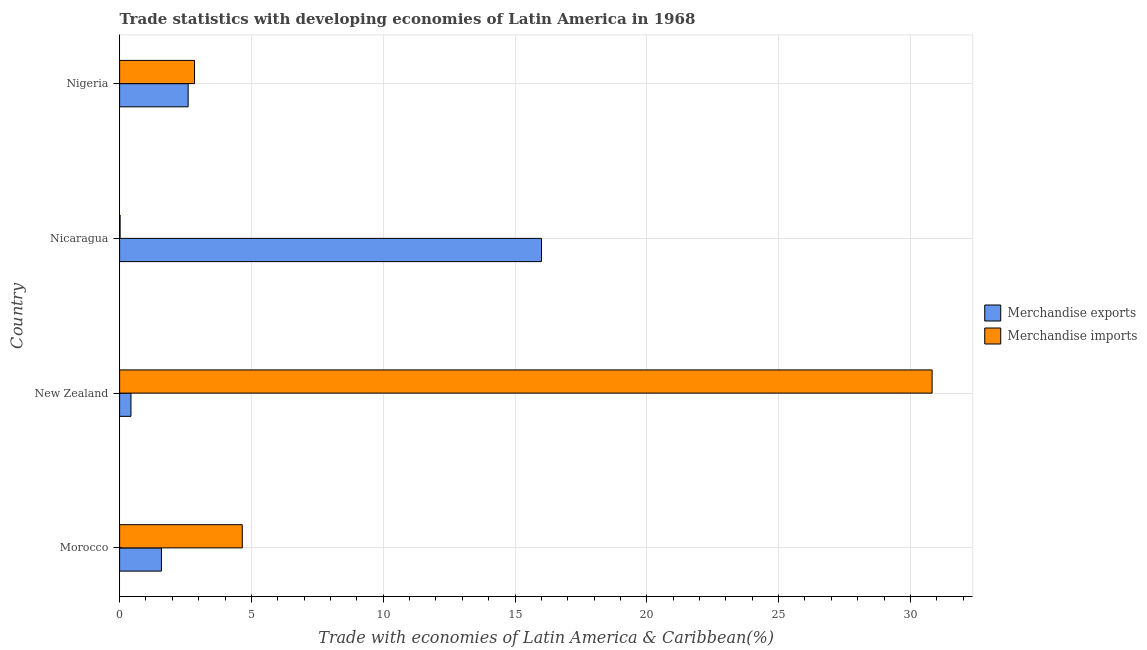How many bars are there on the 4th tick from the top?
Your answer should be compact. 2. How many bars are there on the 4th tick from the bottom?
Offer a terse response. 2. What is the label of the 1st group of bars from the top?
Offer a very short reply. Nigeria. What is the merchandise imports in New Zealand?
Ensure brevity in your answer.  30.82. Across all countries, what is the maximum merchandise exports?
Provide a succinct answer. 16. Across all countries, what is the minimum merchandise imports?
Provide a short and direct response. 0.02. In which country was the merchandise exports maximum?
Provide a short and direct response. Nicaragua. In which country was the merchandise imports minimum?
Provide a short and direct response. Nicaragua. What is the total merchandise imports in the graph?
Offer a terse response. 38.34. What is the difference between the merchandise exports in Morocco and that in New Zealand?
Provide a short and direct response. 1.16. What is the difference between the merchandise imports in New Zealand and the merchandise exports in Nicaragua?
Ensure brevity in your answer.  14.82. What is the average merchandise imports per country?
Ensure brevity in your answer.  9.59. What is the difference between the merchandise exports and merchandise imports in Morocco?
Your answer should be very brief. -3.07. What is the ratio of the merchandise exports in Morocco to that in New Zealand?
Offer a very short reply. 3.68. Is the merchandise imports in New Zealand less than that in Nicaragua?
Your answer should be compact. No. What is the difference between the highest and the second highest merchandise imports?
Offer a terse response. 26.17. What is the difference between the highest and the lowest merchandise imports?
Your answer should be very brief. 30.81. Is the sum of the merchandise imports in Morocco and Nigeria greater than the maximum merchandise exports across all countries?
Keep it short and to the point. No. What does the 1st bar from the top in Morocco represents?
Make the answer very short. Merchandise imports. What does the 1st bar from the bottom in New Zealand represents?
Keep it short and to the point. Merchandise exports. How many bars are there?
Offer a very short reply. 8. Are all the bars in the graph horizontal?
Your answer should be compact. Yes. What is the difference between two consecutive major ticks on the X-axis?
Your answer should be compact. 5. Does the graph contain any zero values?
Offer a very short reply. No. Does the graph contain grids?
Offer a terse response. Yes. Where does the legend appear in the graph?
Keep it short and to the point. Center right. What is the title of the graph?
Make the answer very short. Trade statistics with developing economies of Latin America in 1968. Does "RDB nonconcessional" appear as one of the legend labels in the graph?
Give a very brief answer. No. What is the label or title of the X-axis?
Provide a succinct answer. Trade with economies of Latin America & Caribbean(%). What is the Trade with economies of Latin America & Caribbean(%) of Merchandise exports in Morocco?
Make the answer very short. 1.59. What is the Trade with economies of Latin America & Caribbean(%) of Merchandise imports in Morocco?
Offer a terse response. 4.65. What is the Trade with economies of Latin America & Caribbean(%) of Merchandise exports in New Zealand?
Your response must be concise. 0.43. What is the Trade with economies of Latin America & Caribbean(%) of Merchandise imports in New Zealand?
Keep it short and to the point. 30.82. What is the Trade with economies of Latin America & Caribbean(%) in Merchandise exports in Nicaragua?
Make the answer very short. 16. What is the Trade with economies of Latin America & Caribbean(%) of Merchandise imports in Nicaragua?
Ensure brevity in your answer.  0.02. What is the Trade with economies of Latin America & Caribbean(%) of Merchandise exports in Nigeria?
Your answer should be very brief. 2.6. What is the Trade with economies of Latin America & Caribbean(%) of Merchandise imports in Nigeria?
Your answer should be very brief. 2.84. Across all countries, what is the maximum Trade with economies of Latin America & Caribbean(%) of Merchandise exports?
Give a very brief answer. 16. Across all countries, what is the maximum Trade with economies of Latin America & Caribbean(%) in Merchandise imports?
Give a very brief answer. 30.82. Across all countries, what is the minimum Trade with economies of Latin America & Caribbean(%) of Merchandise exports?
Provide a succinct answer. 0.43. Across all countries, what is the minimum Trade with economies of Latin America & Caribbean(%) of Merchandise imports?
Your answer should be compact. 0.02. What is the total Trade with economies of Latin America & Caribbean(%) in Merchandise exports in the graph?
Give a very brief answer. 20.62. What is the total Trade with economies of Latin America & Caribbean(%) of Merchandise imports in the graph?
Provide a succinct answer. 38.34. What is the difference between the Trade with economies of Latin America & Caribbean(%) of Merchandise exports in Morocco and that in New Zealand?
Make the answer very short. 1.16. What is the difference between the Trade with economies of Latin America & Caribbean(%) in Merchandise imports in Morocco and that in New Zealand?
Your answer should be very brief. -26.17. What is the difference between the Trade with economies of Latin America & Caribbean(%) in Merchandise exports in Morocco and that in Nicaragua?
Make the answer very short. -14.42. What is the difference between the Trade with economies of Latin America & Caribbean(%) in Merchandise imports in Morocco and that in Nicaragua?
Make the answer very short. 4.64. What is the difference between the Trade with economies of Latin America & Caribbean(%) in Merchandise exports in Morocco and that in Nigeria?
Give a very brief answer. -1.01. What is the difference between the Trade with economies of Latin America & Caribbean(%) in Merchandise imports in Morocco and that in Nigeria?
Offer a terse response. 1.81. What is the difference between the Trade with economies of Latin America & Caribbean(%) of Merchandise exports in New Zealand and that in Nicaragua?
Offer a very short reply. -15.57. What is the difference between the Trade with economies of Latin America & Caribbean(%) of Merchandise imports in New Zealand and that in Nicaragua?
Keep it short and to the point. 30.81. What is the difference between the Trade with economies of Latin America & Caribbean(%) of Merchandise exports in New Zealand and that in Nigeria?
Offer a terse response. -2.17. What is the difference between the Trade with economies of Latin America & Caribbean(%) in Merchandise imports in New Zealand and that in Nigeria?
Offer a terse response. 27.98. What is the difference between the Trade with economies of Latin America & Caribbean(%) in Merchandise exports in Nicaragua and that in Nigeria?
Offer a very short reply. 13.4. What is the difference between the Trade with economies of Latin America & Caribbean(%) of Merchandise imports in Nicaragua and that in Nigeria?
Your answer should be very brief. -2.82. What is the difference between the Trade with economies of Latin America & Caribbean(%) in Merchandise exports in Morocco and the Trade with economies of Latin America & Caribbean(%) in Merchandise imports in New Zealand?
Give a very brief answer. -29.24. What is the difference between the Trade with economies of Latin America & Caribbean(%) in Merchandise exports in Morocco and the Trade with economies of Latin America & Caribbean(%) in Merchandise imports in Nicaragua?
Your answer should be compact. 1.57. What is the difference between the Trade with economies of Latin America & Caribbean(%) in Merchandise exports in Morocco and the Trade with economies of Latin America & Caribbean(%) in Merchandise imports in Nigeria?
Provide a short and direct response. -1.26. What is the difference between the Trade with economies of Latin America & Caribbean(%) in Merchandise exports in New Zealand and the Trade with economies of Latin America & Caribbean(%) in Merchandise imports in Nicaragua?
Provide a short and direct response. 0.41. What is the difference between the Trade with economies of Latin America & Caribbean(%) in Merchandise exports in New Zealand and the Trade with economies of Latin America & Caribbean(%) in Merchandise imports in Nigeria?
Offer a very short reply. -2.41. What is the difference between the Trade with economies of Latin America & Caribbean(%) in Merchandise exports in Nicaragua and the Trade with economies of Latin America & Caribbean(%) in Merchandise imports in Nigeria?
Give a very brief answer. 13.16. What is the average Trade with economies of Latin America & Caribbean(%) in Merchandise exports per country?
Offer a very short reply. 5.16. What is the average Trade with economies of Latin America & Caribbean(%) in Merchandise imports per country?
Offer a terse response. 9.58. What is the difference between the Trade with economies of Latin America & Caribbean(%) in Merchandise exports and Trade with economies of Latin America & Caribbean(%) in Merchandise imports in Morocco?
Make the answer very short. -3.07. What is the difference between the Trade with economies of Latin America & Caribbean(%) of Merchandise exports and Trade with economies of Latin America & Caribbean(%) of Merchandise imports in New Zealand?
Ensure brevity in your answer.  -30.39. What is the difference between the Trade with economies of Latin America & Caribbean(%) in Merchandise exports and Trade with economies of Latin America & Caribbean(%) in Merchandise imports in Nicaragua?
Give a very brief answer. 15.99. What is the difference between the Trade with economies of Latin America & Caribbean(%) in Merchandise exports and Trade with economies of Latin America & Caribbean(%) in Merchandise imports in Nigeria?
Your response must be concise. -0.24. What is the ratio of the Trade with economies of Latin America & Caribbean(%) in Merchandise exports in Morocco to that in New Zealand?
Provide a succinct answer. 3.68. What is the ratio of the Trade with economies of Latin America & Caribbean(%) of Merchandise imports in Morocco to that in New Zealand?
Your response must be concise. 0.15. What is the ratio of the Trade with economies of Latin America & Caribbean(%) of Merchandise exports in Morocco to that in Nicaragua?
Ensure brevity in your answer.  0.1. What is the ratio of the Trade with economies of Latin America & Caribbean(%) in Merchandise imports in Morocco to that in Nicaragua?
Your response must be concise. 251.18. What is the ratio of the Trade with economies of Latin America & Caribbean(%) in Merchandise exports in Morocco to that in Nigeria?
Provide a short and direct response. 0.61. What is the ratio of the Trade with economies of Latin America & Caribbean(%) in Merchandise imports in Morocco to that in Nigeria?
Offer a very short reply. 1.64. What is the ratio of the Trade with economies of Latin America & Caribbean(%) of Merchandise exports in New Zealand to that in Nicaragua?
Provide a short and direct response. 0.03. What is the ratio of the Trade with economies of Latin America & Caribbean(%) of Merchandise imports in New Zealand to that in Nicaragua?
Offer a terse response. 1663.56. What is the ratio of the Trade with economies of Latin America & Caribbean(%) in Merchandise exports in New Zealand to that in Nigeria?
Provide a short and direct response. 0.17. What is the ratio of the Trade with economies of Latin America & Caribbean(%) in Merchandise imports in New Zealand to that in Nigeria?
Offer a terse response. 10.84. What is the ratio of the Trade with economies of Latin America & Caribbean(%) of Merchandise exports in Nicaragua to that in Nigeria?
Provide a succinct answer. 6.15. What is the ratio of the Trade with economies of Latin America & Caribbean(%) in Merchandise imports in Nicaragua to that in Nigeria?
Provide a succinct answer. 0.01. What is the difference between the highest and the second highest Trade with economies of Latin America & Caribbean(%) of Merchandise exports?
Offer a very short reply. 13.4. What is the difference between the highest and the second highest Trade with economies of Latin America & Caribbean(%) in Merchandise imports?
Ensure brevity in your answer.  26.17. What is the difference between the highest and the lowest Trade with economies of Latin America & Caribbean(%) in Merchandise exports?
Make the answer very short. 15.57. What is the difference between the highest and the lowest Trade with economies of Latin America & Caribbean(%) in Merchandise imports?
Provide a succinct answer. 30.81. 